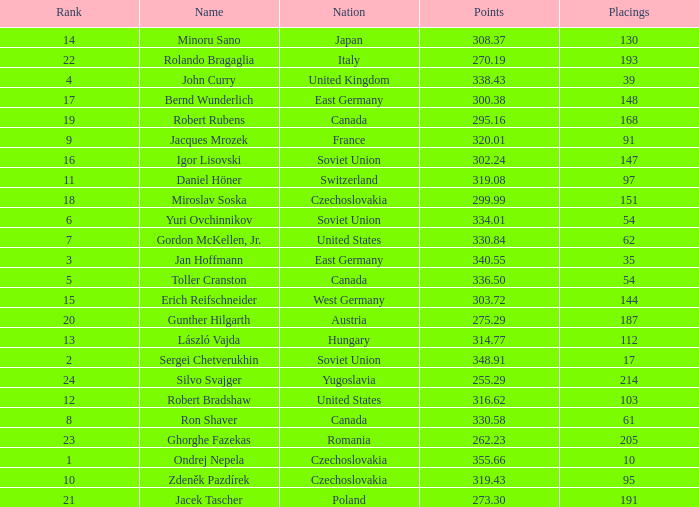How many Placings have Points smaller than 330.84, and a Name of silvo svajger? 1.0. 